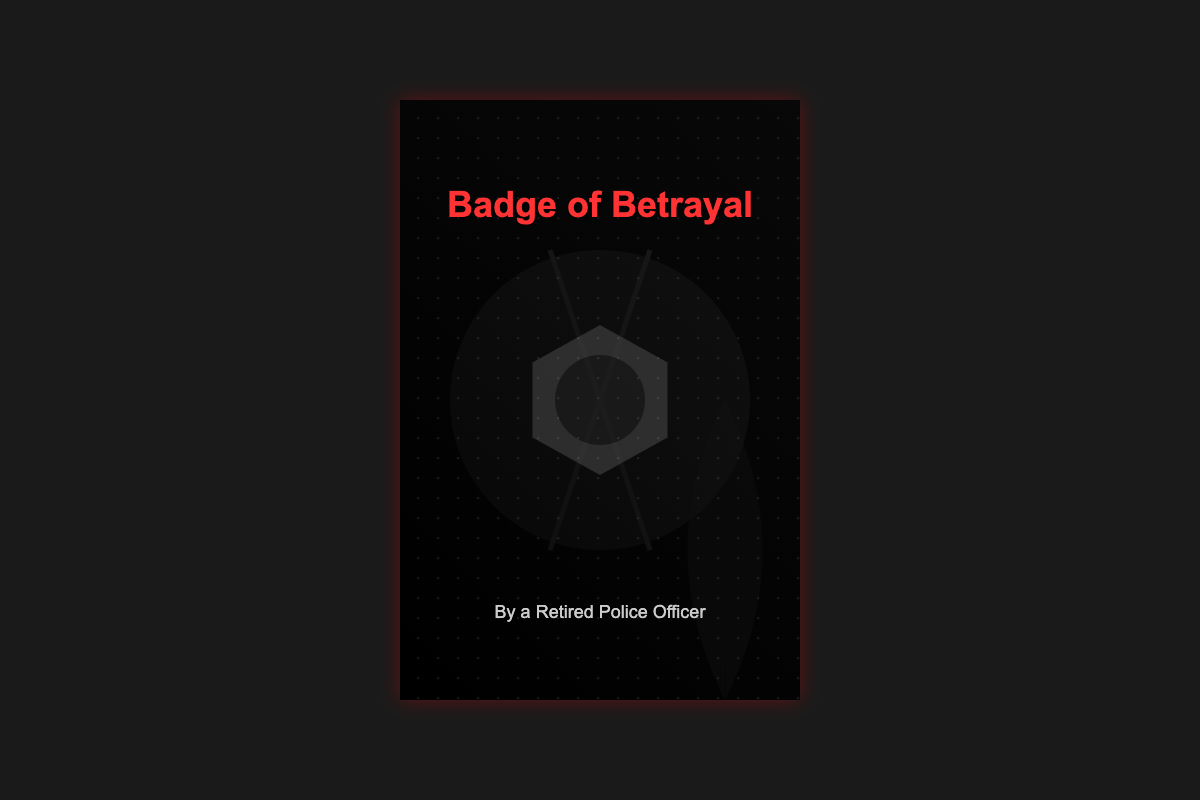what is the title of the book? The title of the book is prominently displayed in bold red letters at the top of the cover.
Answer: Badge of Betrayal who is the author of the book? The author is mentioned at the bottom of the cover in a smaller font.
Answer: By a Retired Police Officer what color is the title text? The title text is a distinct and eye-catching color that stands out against the dark background.
Answer: Red what type of imagery is found in the background? The cover features a dramatic scene with a badge and a shadowy figure, hinting at themes of betrayal.
Answer: Dark and shadowy what element symbolizes tension in the cover? The use of bold red lettering signifies high stakes and tension throughout the visual design.
Answer: Title color what does the badge represent in the cover? The badge cast aside represents themes of loyalty, betrayal, or an officer’s conflict in the narrative.
Answer: Betrayal what visual element adds a sense of depth to the cover? The background elements, particularly the layering of shadows and rain, create a mood of suspense and depth.
Answer: Shadows and raindrops what does the overall color scheme suggest? The use of dark colors contrasted with red suggests danger and urgency in the storyline.
Answer: Danger and urgency 